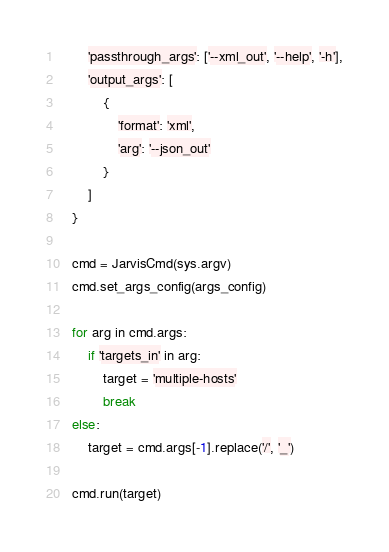<code> <loc_0><loc_0><loc_500><loc_500><_Python_>		'passthrough_args': ['--xml_out', '--help', '-h'],
		'output_args': [
			{
				'format': 'xml',
				'arg': '--json_out'
			}
		]
	}

	cmd = JarvisCmd(sys.argv)
	cmd.set_args_config(args_config)

	for arg in cmd.args:
		if 'targets_in' in arg:
			target = 'multiple-hosts'
			break
	else:
		target = cmd.args[-1].replace('/', '_')

	cmd.run(target)
</code> 